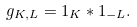Convert formula to latex. <formula><loc_0><loc_0><loc_500><loc_500>g _ { K , L } = 1 _ { K } \ast 1 _ { - L } .</formula> 